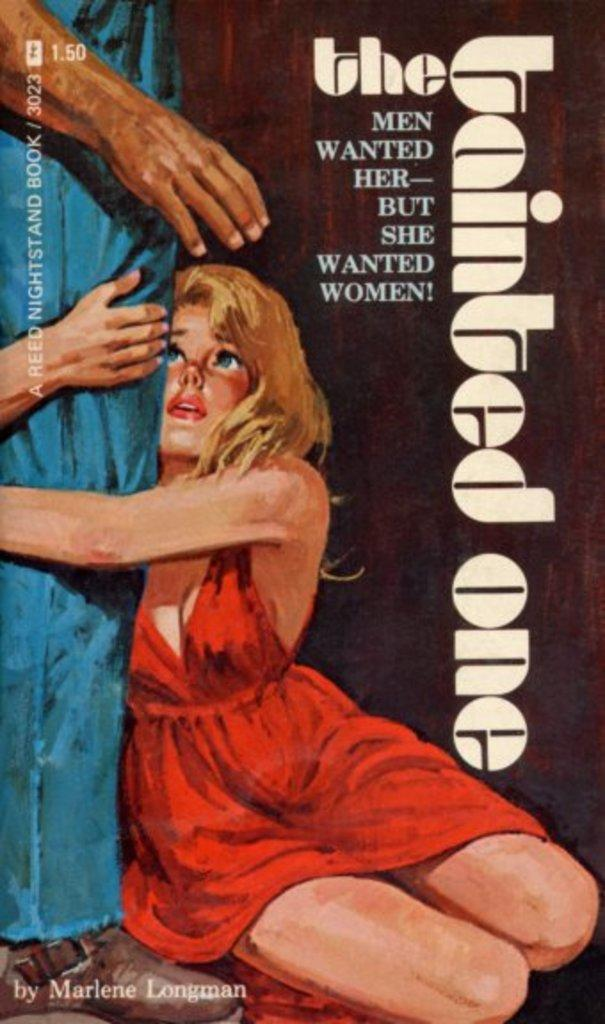<image>
Create a compact narrative representing the image presented. The cover of The Tainted One has a girl wearing a red dress. 